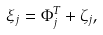<formula> <loc_0><loc_0><loc_500><loc_500>\xi _ { j } = \Phi _ { j } ^ { T } + \zeta _ { j } ,</formula> 